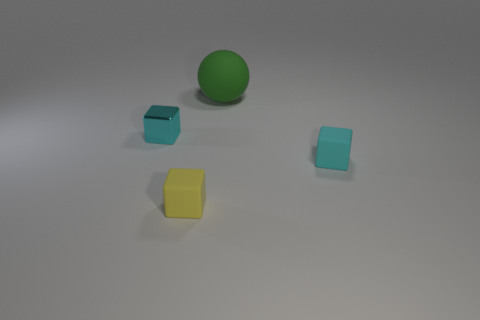Add 1 large cubes. How many objects exist? 5 Subtract all yellow blocks. Subtract all cyan balls. How many blocks are left? 2 Subtract all spheres. How many objects are left? 3 Subtract 0 gray blocks. How many objects are left? 4 Subtract all small yellow metal cylinders. Subtract all green matte objects. How many objects are left? 3 Add 4 blocks. How many blocks are left? 7 Add 3 gray metallic cylinders. How many gray metallic cylinders exist? 3 